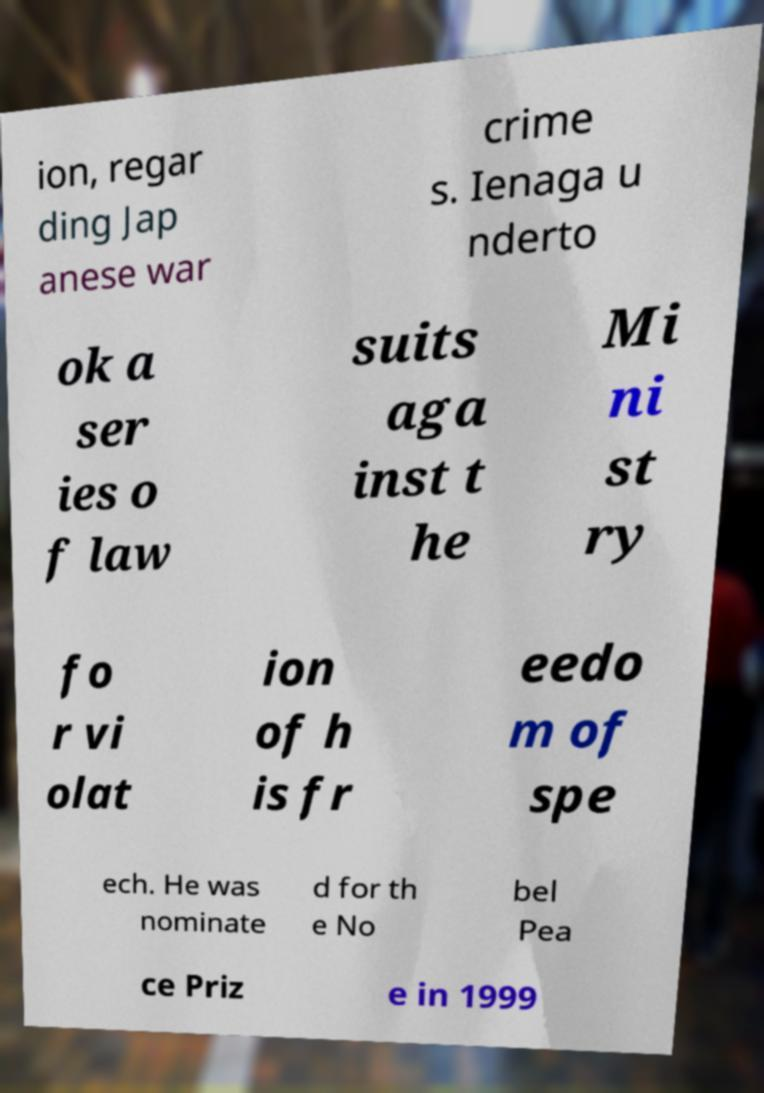There's text embedded in this image that I need extracted. Can you transcribe it verbatim? ion, regar ding Jap anese war crime s. Ienaga u nderto ok a ser ies o f law suits aga inst t he Mi ni st ry fo r vi olat ion of h is fr eedo m of spe ech. He was nominate d for th e No bel Pea ce Priz e in 1999 